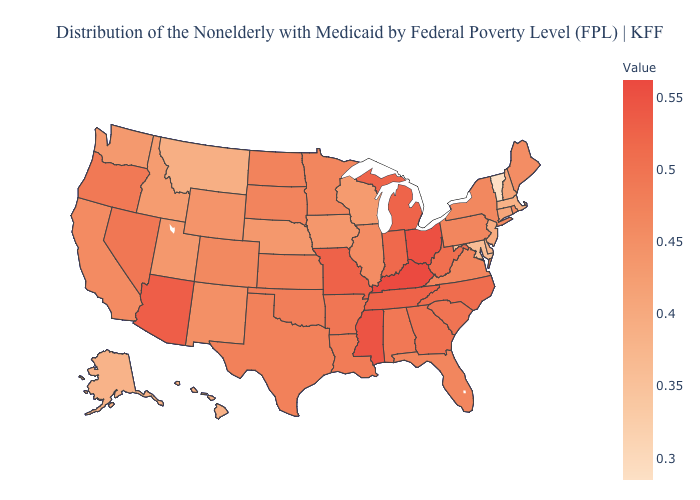Among the states that border Texas , which have the highest value?
Give a very brief answer. Arkansas. Among the states that border Missouri , does Nebraska have the lowest value?
Keep it brief. Yes. Does Maryland have the lowest value in the South?
Keep it brief. Yes. Which states have the lowest value in the Northeast?
Short answer required. Vermont. Which states hav the highest value in the West?
Answer briefly. Arizona. Does Vermont have the lowest value in the USA?
Be succinct. Yes. Does West Virginia have the highest value in the USA?
Write a very short answer. No. Which states hav the highest value in the Northeast?
Write a very short answer. Pennsylvania. 